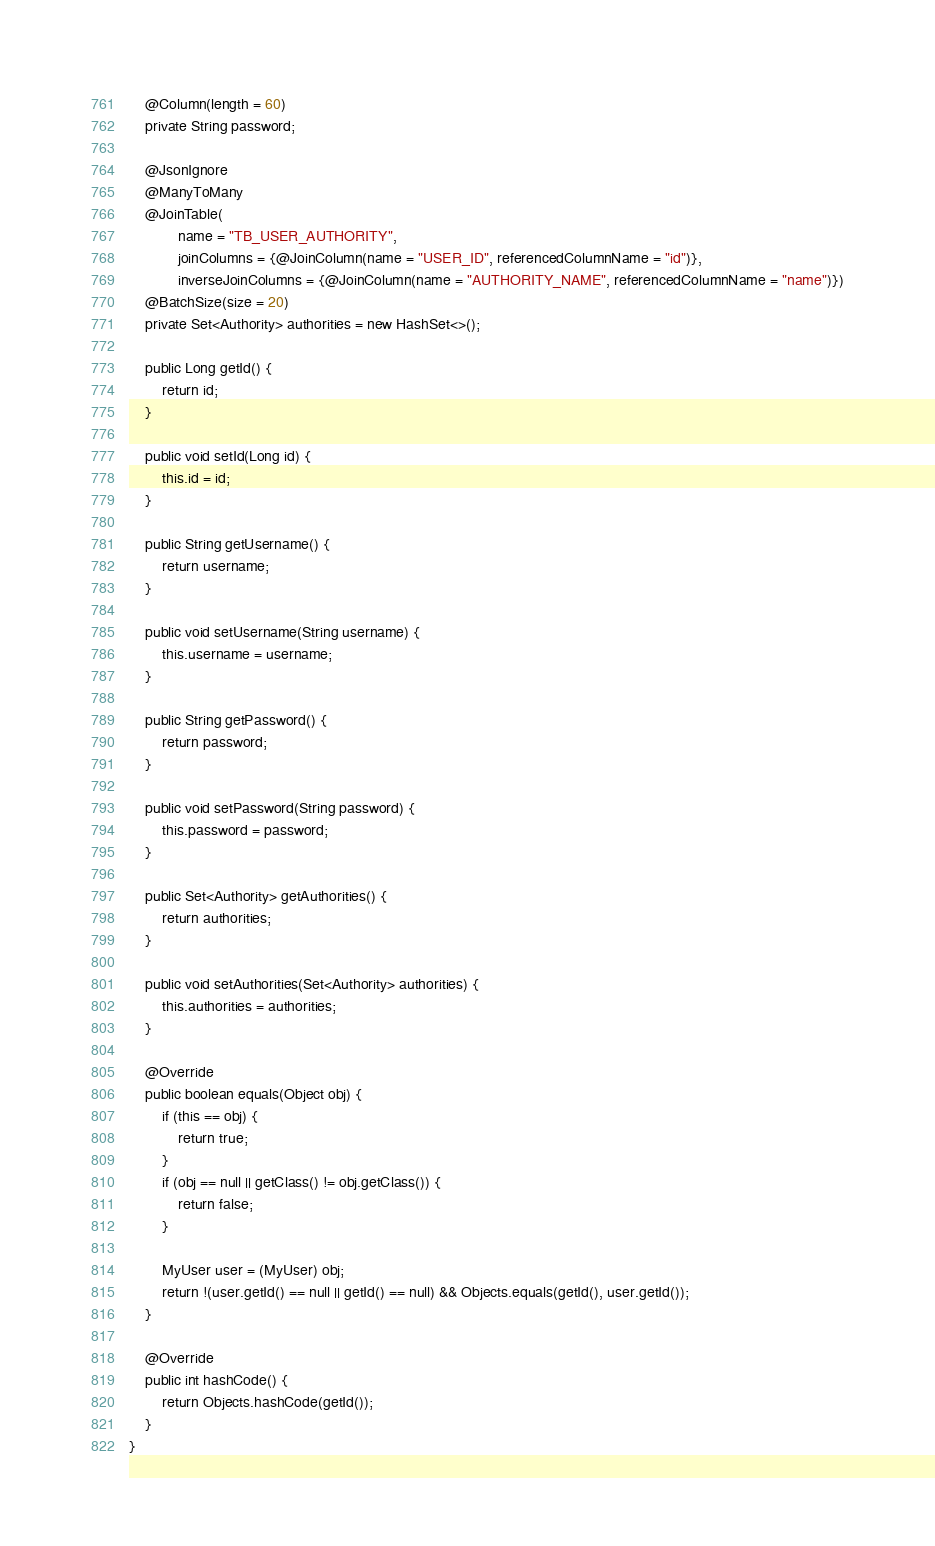Convert code to text. <code><loc_0><loc_0><loc_500><loc_500><_Java_>    @Column(length = 60)
    private String password;

    @JsonIgnore
    @ManyToMany
    @JoinTable(
            name = "TB_USER_AUTHORITY",
            joinColumns = {@JoinColumn(name = "USER_ID", referencedColumnName = "id")},
            inverseJoinColumns = {@JoinColumn(name = "AUTHORITY_NAME", referencedColumnName = "name")})
    @BatchSize(size = 20)
    private Set<Authority> authorities = new HashSet<>();

    public Long getId() {
        return id;
    }

    public void setId(Long id) {
        this.id = id;
    }

    public String getUsername() {
        return username;
    }

    public void setUsername(String username) {
        this.username = username;
    }

    public String getPassword() {
        return password;
    }

    public void setPassword(String password) {
        this.password = password;
    }

    public Set<Authority> getAuthorities() {
        return authorities;
    }

    public void setAuthorities(Set<Authority> authorities) {
        this.authorities = authorities;
    }

    @Override
    public boolean equals(Object obj) {
        if (this == obj) {
            return true;
        }
        if (obj == null || getClass() != obj.getClass()) {
            return false;
        }

        MyUser user = (MyUser) obj;
        return !(user.getId() == null || getId() == null) && Objects.equals(getId(), user.getId());
    }

    @Override
    public int hashCode() {
        return Objects.hashCode(getId());
    }
}
</code> 